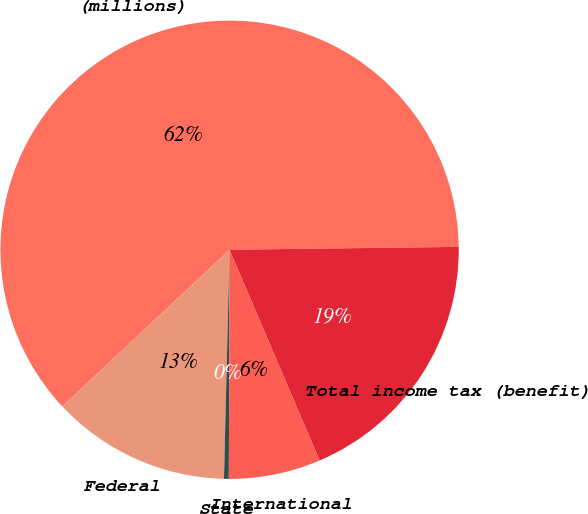<chart> <loc_0><loc_0><loc_500><loc_500><pie_chart><fcel>(millions)<fcel>Federal<fcel>State<fcel>International<fcel>Total income tax (benefit)<nl><fcel>61.78%<fcel>12.63%<fcel>0.34%<fcel>6.48%<fcel>18.77%<nl></chart> 